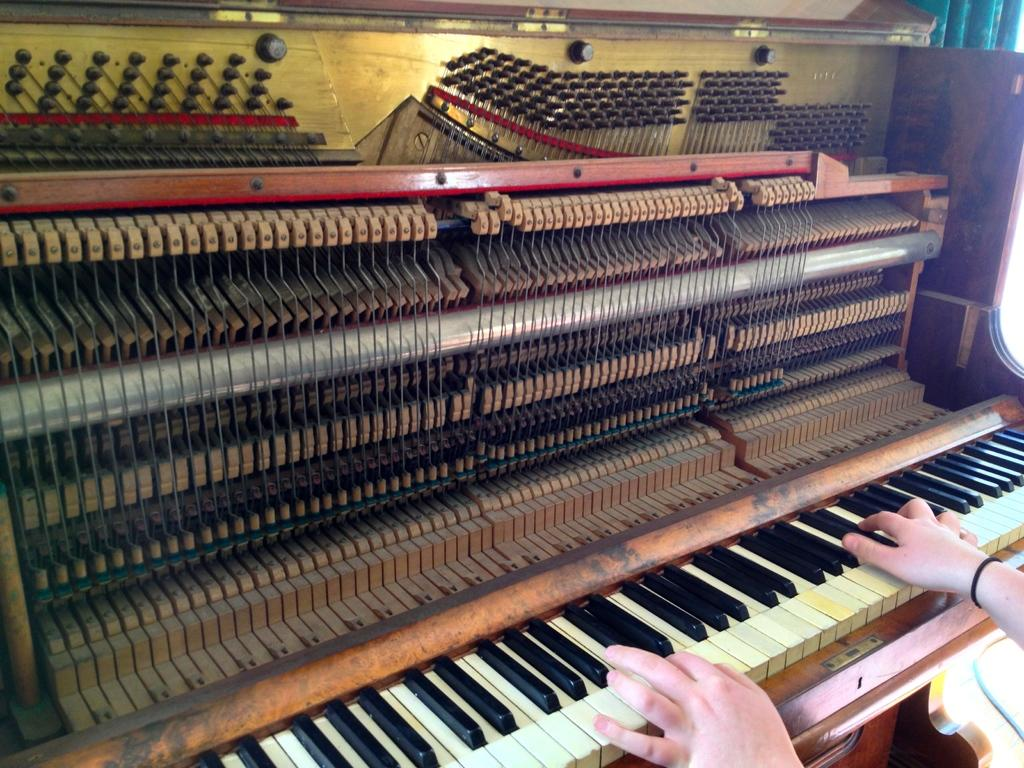What is the person in the image doing? The person is playing a piano. Can you describe the piano in the image? The piano is brown in color and has yellow buttons. How many screws can be seen holding the person to the piano in the image? There are no screws visible in the image, and the person is not physically attached to the piano. 